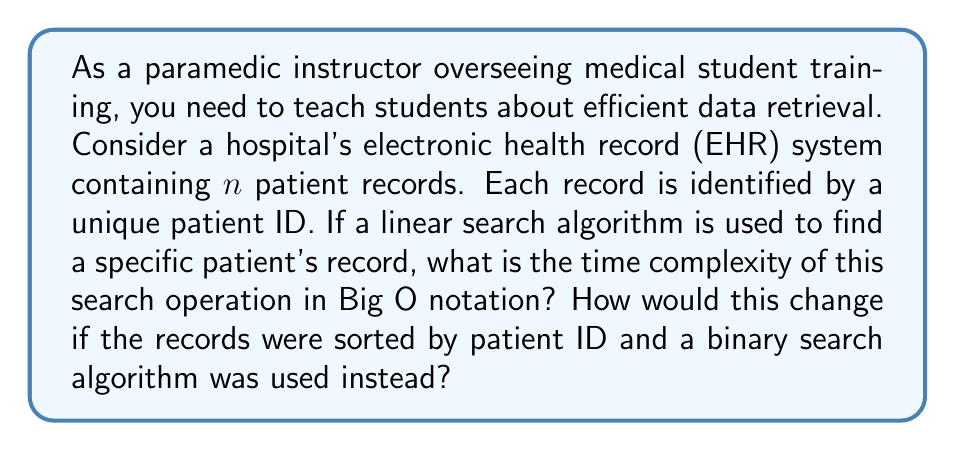Help me with this question. To answer this question, we need to consider the time complexity of both linear search and binary search algorithms:

1. Linear Search:
   - In a linear search, we check each record sequentially until we find the desired patient ID.
   - In the worst case, we might need to check all $n$ records.
   - The time complexity of linear search is $O(n)$, where $n$ is the number of records.

2. Binary Search:
   - Binary search can only be used if the records are sorted by patient ID.
   - It repeatedly divides the search interval in half.
   - In each step, we compare the middle element with the target patient ID.
   - The number of comparisons is at most $\log_2(n)$.
   - The time complexity of binary search is $O(\log n)$.

Comparison:
- Linear search: $O(n)$
- Binary search: $O(\log n)$

For large datasets, binary search is significantly more efficient. For example:
- If $n = 1,000,000$:
  - Linear search might require up to 1,000,000 comparisons
  - Binary search would require at most $\log_2(1,000,000) \approx 20$ comparisons

However, it's important to note that binary search requires the data to be sorted, which has its own time complexity implications for inserting new records or updating existing ones.
Answer: The time complexity for linear search is $O(n)$, and for binary search (if records are sorted) is $O(\log n)$. 